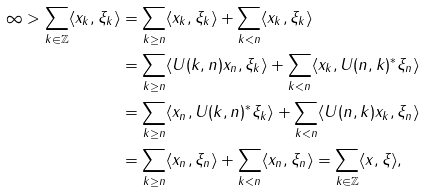<formula> <loc_0><loc_0><loc_500><loc_500>\infty > \sum _ { k \in \mathbb { Z } } \langle x _ { k } , \xi _ { k } \rangle & = \sum _ { k \geq n } \langle x _ { k } , \xi _ { k } \rangle + \sum _ { k < n } \langle x _ { k } , \xi _ { k } \rangle \\ & = \sum _ { k \geq n } \langle U ( k , n ) x _ { n } , \xi _ { k } \rangle + \sum _ { k < n } \langle x _ { k } , U ( n , k ) ^ { * } \xi _ { n } \rangle \\ & = \sum _ { k \geq n } \langle x _ { n } , U ( k , n ) ^ { * } \xi _ { k } \rangle + \sum _ { k < n } \langle U ( n , k ) x _ { k } , \xi _ { n } \rangle \\ & = \sum _ { k \geq n } \langle x _ { n } , \xi _ { n } \rangle + \sum _ { k < n } \langle x _ { n } , \xi _ { n } \rangle = \sum _ { k \in \mathbb { Z } } \langle x , \xi \rangle ,</formula> 